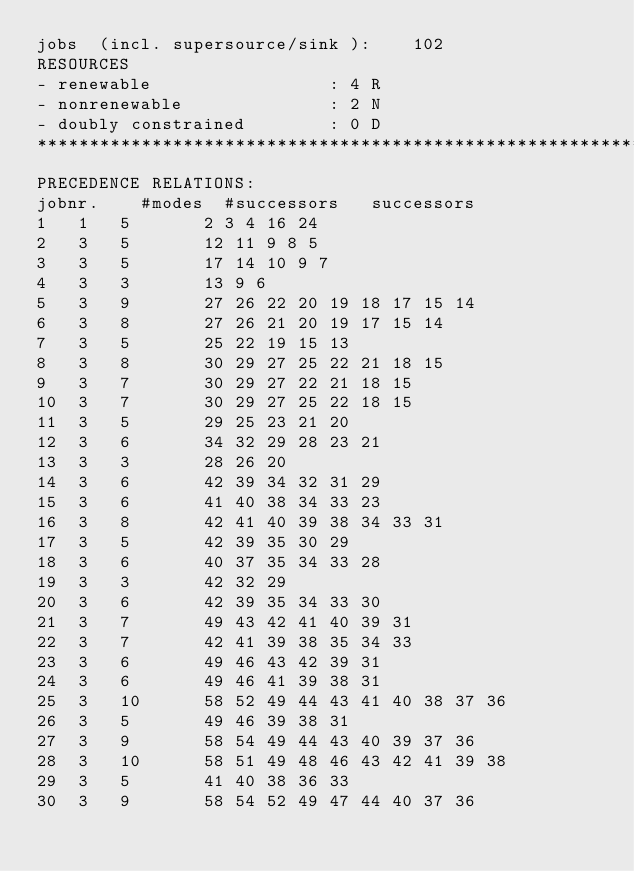<code> <loc_0><loc_0><loc_500><loc_500><_ObjectiveC_>jobs  (incl. supersource/sink ):	102
RESOURCES
- renewable                 : 4 R
- nonrenewable              : 2 N
- doubly constrained        : 0 D
************************************************************************
PRECEDENCE RELATIONS:
jobnr.    #modes  #successors   successors
1	1	5		2 3 4 16 24 
2	3	5		12 11 9 8 5 
3	3	5		17 14 10 9 7 
4	3	3		13 9 6 
5	3	9		27 26 22 20 19 18 17 15 14 
6	3	8		27 26 21 20 19 17 15 14 
7	3	5		25 22 19 15 13 
8	3	8		30 29 27 25 22 21 18 15 
9	3	7		30 29 27 22 21 18 15 
10	3	7		30 29 27 25 22 18 15 
11	3	5		29 25 23 21 20 
12	3	6		34 32 29 28 23 21 
13	3	3		28 26 20 
14	3	6		42 39 34 32 31 29 
15	3	6		41 40 38 34 33 23 
16	3	8		42 41 40 39 38 34 33 31 
17	3	5		42 39 35 30 29 
18	3	6		40 37 35 34 33 28 
19	3	3		42 32 29 
20	3	6		42 39 35 34 33 30 
21	3	7		49 43 42 41 40 39 31 
22	3	7		42 41 39 38 35 34 33 
23	3	6		49 46 43 42 39 31 
24	3	6		49 46 41 39 38 31 
25	3	10		58 52 49 44 43 41 40 38 37 36 
26	3	5		49 46 39 38 31 
27	3	9		58 54 49 44 43 40 39 37 36 
28	3	10		58 51 49 48 46 43 42 41 39 38 
29	3	5		41 40 38 36 33 
30	3	9		58 54 52 49 47 44 40 37 36 </code> 